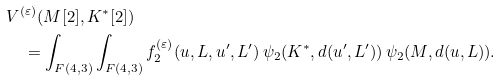<formula> <loc_0><loc_0><loc_500><loc_500>& V ^ { ( \varepsilon ) } ( M [ 2 ] , K ^ { * } [ 2 ] ) \\ & \quad = \int _ { F ( 4 , 3 ) } \int _ { F ( 4 , 3 ) } f _ { 2 } ^ { ( \varepsilon ) } ( u , L , u ^ { \prime } , L ^ { \prime } ) \, \psi _ { 2 } ( K ^ { * } , d ( u ^ { \prime } , L ^ { \prime } ) ) \, \psi _ { 2 } ( M , d ( u , L ) ) .</formula> 